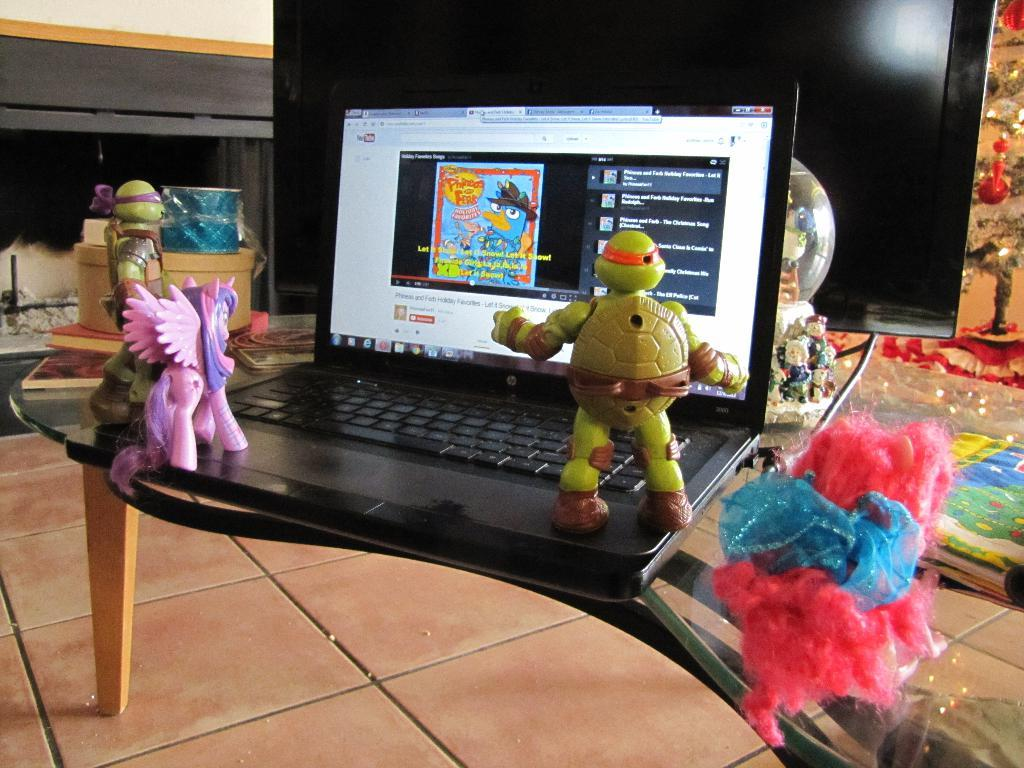What is the main piece of furniture in the image? There is a table in the image. What electronic device is placed on the table? A laptop is placed on the table. What is located in front of the laptop? There is a TV in front of the laptop. What type of objects are placed on the laptop? Toys are placed on the laptop. What type of leaf can be seen falling from the carriage in the image? There is no leaf or carriage present in the image. 